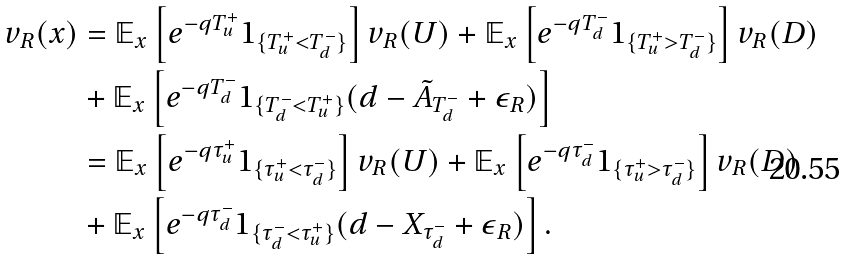<formula> <loc_0><loc_0><loc_500><loc_500>v _ { R } ( x ) & = \mathbb { E } _ { x } \left [ e ^ { - q T _ { u } ^ { + } } 1 _ { \{ T _ { u } ^ { + } < T _ { d } ^ { - } \} } \right ] v _ { R } ( U ) + \mathbb { E } _ { x } \left [ e ^ { - q T _ { d } ^ { - } } 1 _ { \{ T _ { u } ^ { + } > T _ { d } ^ { - } \} } \right ] v _ { R } ( D ) \\ & + \mathbb { E } _ { x } \left [ e ^ { - q T _ { d } ^ { - } } 1 _ { \{ T _ { d } ^ { - } < T _ { u } ^ { + } \} } ( d - \tilde { A } _ { T _ { d } ^ { - } } + \epsilon _ { R } ) \right ] \\ & = \mathbb { E } _ { x } \left [ e ^ { - q \tau _ { u } ^ { + } } 1 _ { \{ \tau _ { u } ^ { + } < \tau _ { d } ^ { - } \} } \right ] v _ { R } ( U ) + \mathbb { E } _ { x } \left [ e ^ { - q \tau _ { d } ^ { - } } 1 _ { \{ \tau _ { u } ^ { + } > \tau _ { d } ^ { - } \} } \right ] v _ { R } ( D ) \\ & + \mathbb { E } _ { x } \left [ e ^ { - q \tau _ { d } ^ { - } } 1 _ { \{ \tau _ { d } ^ { - } < \tau _ { u } ^ { + } \} } ( d - X _ { \tau _ { d } ^ { - } } + \epsilon _ { R } ) \right ] .</formula> 